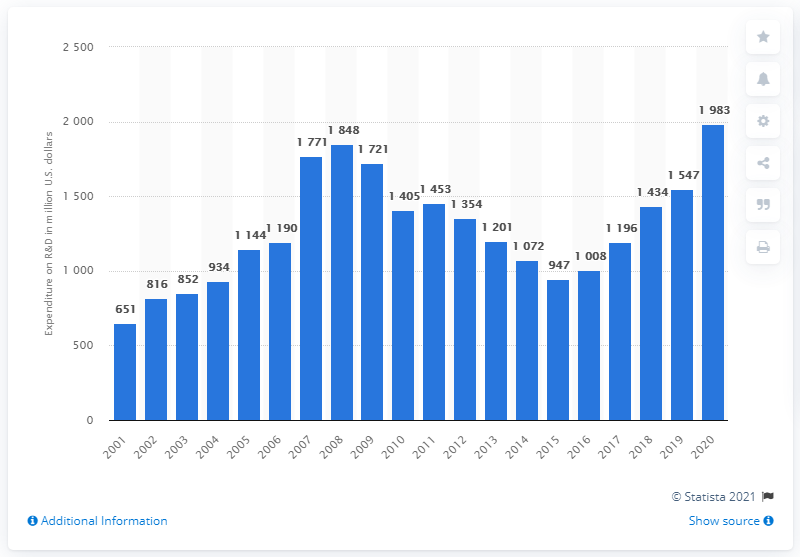List a handful of essential elements in this visual. AMD reported that they spent $1.51 billion on research and development in 2020, which represents a significant increase from the $1.38 billion spent in 2019. This investment in R&D has allowed AMD to develop new and innovative products, such as their high-performance Ryzen processors and powerful Radeon graphics cards, which have helped the company to regain market share and grow its revenue. AMD's expenditure on R&D in 2019 was 1547. 